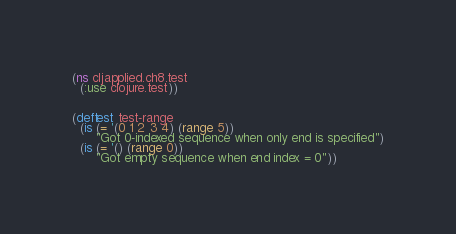<code> <loc_0><loc_0><loc_500><loc_500><_Clojure_>(ns cljapplied.ch8.test
  (:use clojure.test))


(deftest test-range
  (is (= '(0 1 2 3 4) (range 5))
      "Got 0-indexed sequence when only end is specified")
  (is (= '() (range 0))
      "Got empty sequence when end index = 0"))
</code> 